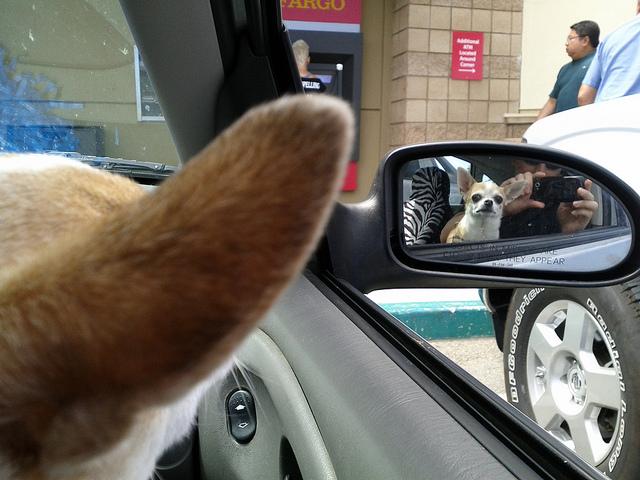What kind of dog is shown?
Be succinct. Chihuahua. How many wheels are visible?
Quick response, please. 1. Is the dog looking at the car mirror?
Concise answer only. Yes. 